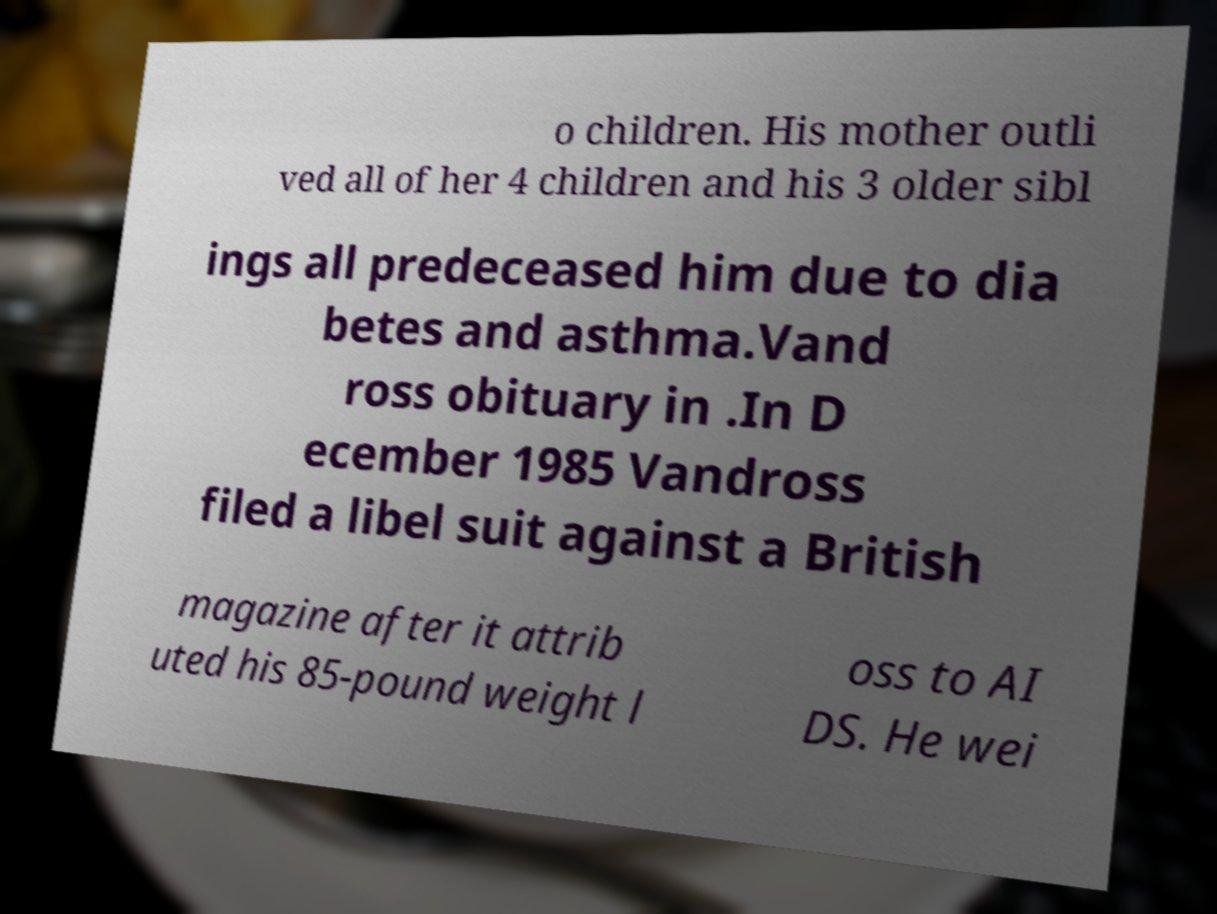Please read and relay the text visible in this image. What does it say? o children. His mother outli ved all of her 4 children and his 3 older sibl ings all predeceased him due to dia betes and asthma.Vand ross obituary in .In D ecember 1985 Vandross filed a libel suit against a British magazine after it attrib uted his 85-pound weight l oss to AI DS. He wei 